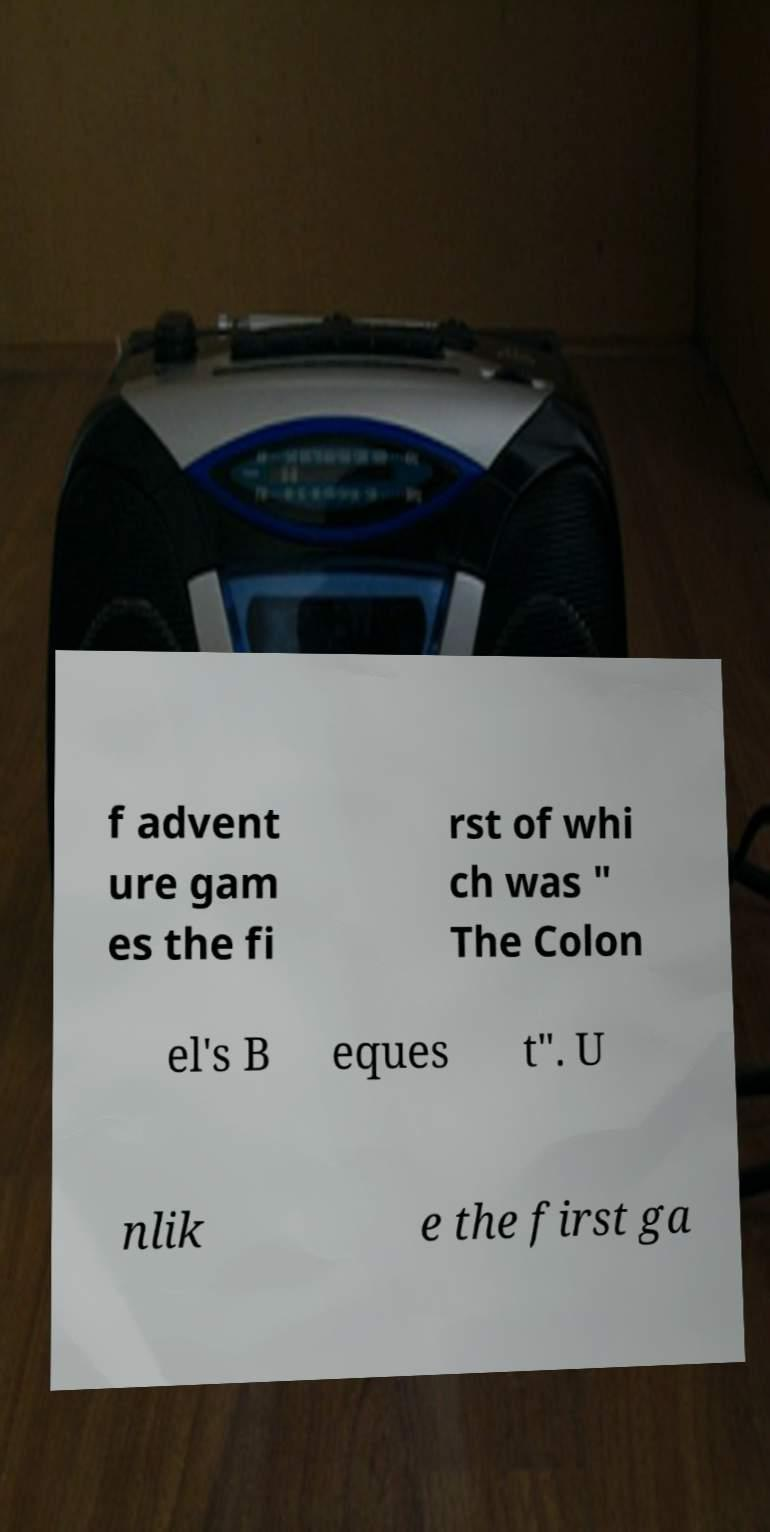For documentation purposes, I need the text within this image transcribed. Could you provide that? f advent ure gam es the fi rst of whi ch was " The Colon el's B eques t". U nlik e the first ga 